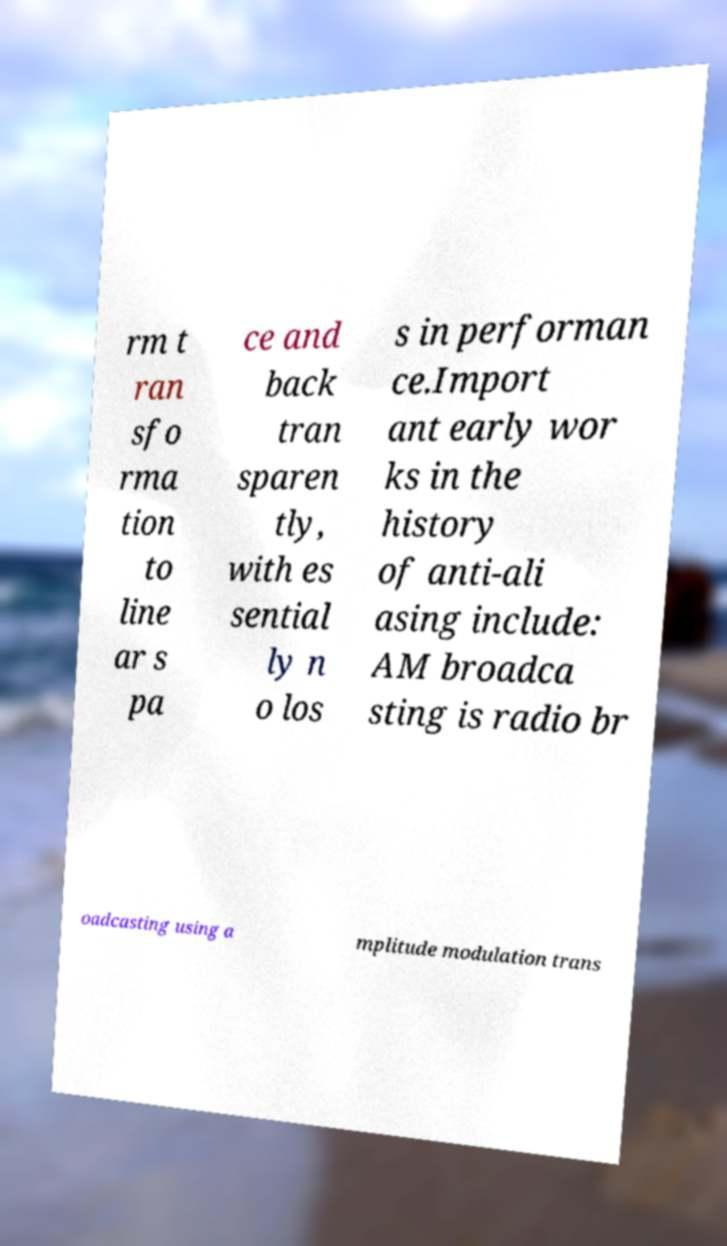Can you read and provide the text displayed in the image?This photo seems to have some interesting text. Can you extract and type it out for me? rm t ran sfo rma tion to line ar s pa ce and back tran sparen tly, with es sential ly n o los s in performan ce.Import ant early wor ks in the history of anti-ali asing include: AM broadca sting is radio br oadcasting using a mplitude modulation trans 